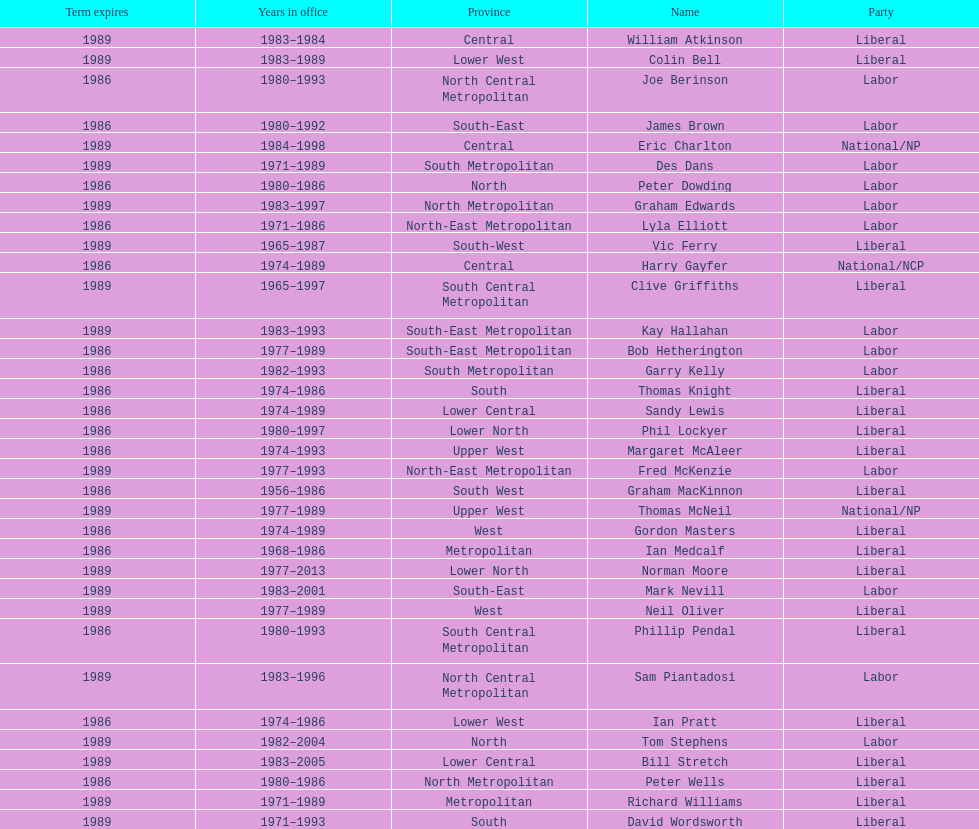What was phil lockyer's party? Liberal. 